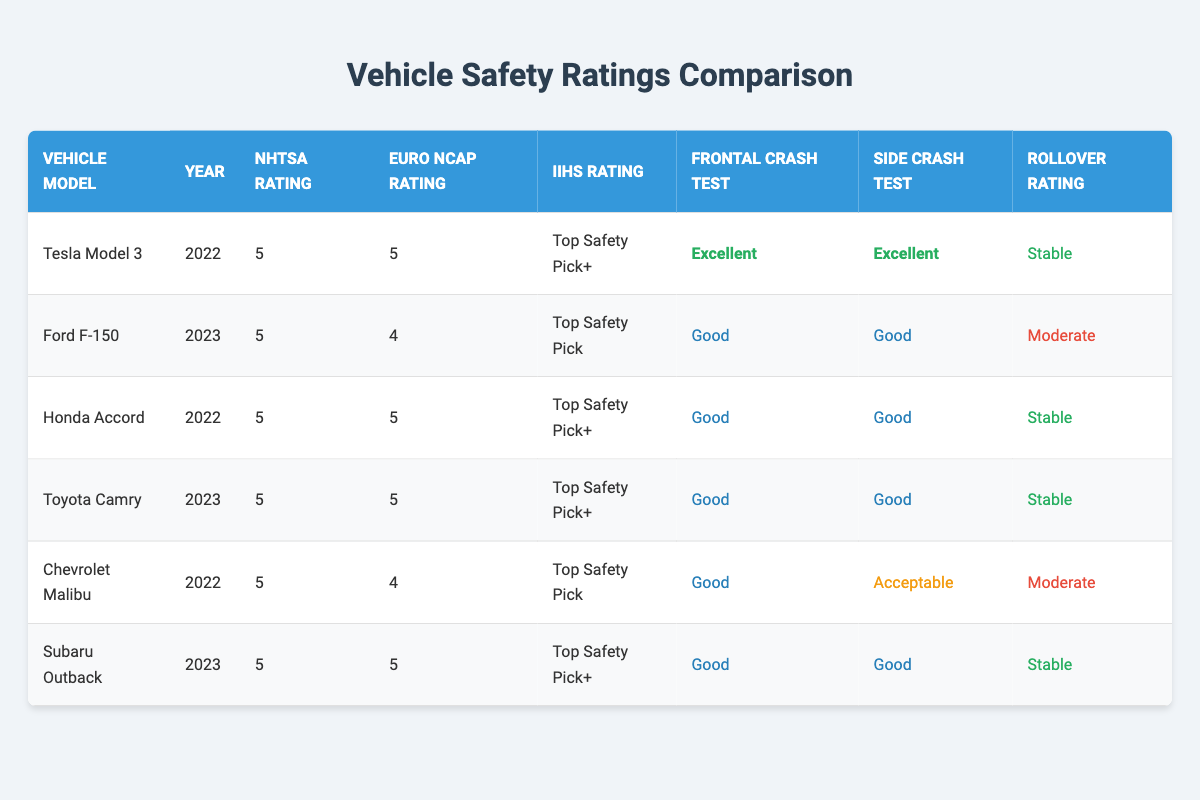What is the highest NHTSA rating among the vehicle models listed? Looking at the NHTSA Rating column, all vehicle models listed have a rating of 5, which is the highest possible value.
Answer: 5 Which vehicle model has the IIHS rating of "Top Safety Pick+"? By scanning the IIHS Rating column, the vehicle models with "Top Safety Pick+" are the Tesla Model 3, Honda Accord, Toyota Camry, and Subaru Outback.
Answer: Tesla Model 3, Honda Accord, Toyota Camry, Subaru Outback What is the Frontal Crash Test Score for the Ford F-150? Referencing the Frontal Crash Test Score column for the Ford F-150, the score is listed as "Good."
Answer: Good Is the Rollover Rating for the Chevrolet Malibu stable? The Rollover Rating for the Chevrolet Malibu is "Moderate" according to the table. Therefore, the statement is false.
Answer: No Which vehicle has the best ratings across all three parameters (NHTSA, Euro NCAP, IIHS) in the latest year? Checking both the NHTSA and Euro NCAP ratings along with the IIHS ratings for 2023 vehicles, the Toyota Camry and Subaru Outback have 5 stars in both NHTSA and Euro NCAP, along with "Top Safety Pick+" for IIHS. Thus, they perform the best in their respective year for all three parameters.
Answer: Toyota Camry, Subaru Outback What is the average Euro NCAP rating for the vehicles listed? The Euro NCAP ratings for the listed vehicles are 5, 4, 5, 5, 4, and 5. Summing these values gives 28, and dividing by the number of vehicles (6) results in an average Euro NCAP rating of 4.67.
Answer: 4.67 Is there any vehicle model from 2022 that has a Euro NCAP rating of 4? The Chevrolet Malibu from 2022 has a Euro NCAP rating of 4, so the answer is yes.
Answer: Yes What percentage of vehicle models received a Rollover Rating of "Stable"? Out of the 6 vehicle models listed, 4 received a Rollover Rating of "Stable." This is calculated as (4/6) * 100%, which equals approximately 66.67%.
Answer: 66.67% Which vehicle models have a Frontal Crash Test Score classified as "Acceptable"? The table shows that the Chevrolet Malibu has a Frontal Crash Test Score classified as "Acceptable." Checking through all the vehicles reveals that it is the only model with this score.
Answer: Chevrolet Malibu 